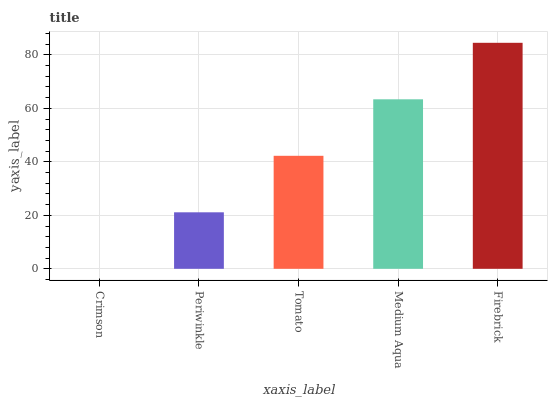Is Crimson the minimum?
Answer yes or no. Yes. Is Firebrick the maximum?
Answer yes or no. Yes. Is Periwinkle the minimum?
Answer yes or no. No. Is Periwinkle the maximum?
Answer yes or no. No. Is Periwinkle greater than Crimson?
Answer yes or no. Yes. Is Crimson less than Periwinkle?
Answer yes or no. Yes. Is Crimson greater than Periwinkle?
Answer yes or no. No. Is Periwinkle less than Crimson?
Answer yes or no. No. Is Tomato the high median?
Answer yes or no. Yes. Is Tomato the low median?
Answer yes or no. Yes. Is Medium Aqua the high median?
Answer yes or no. No. Is Crimson the low median?
Answer yes or no. No. 